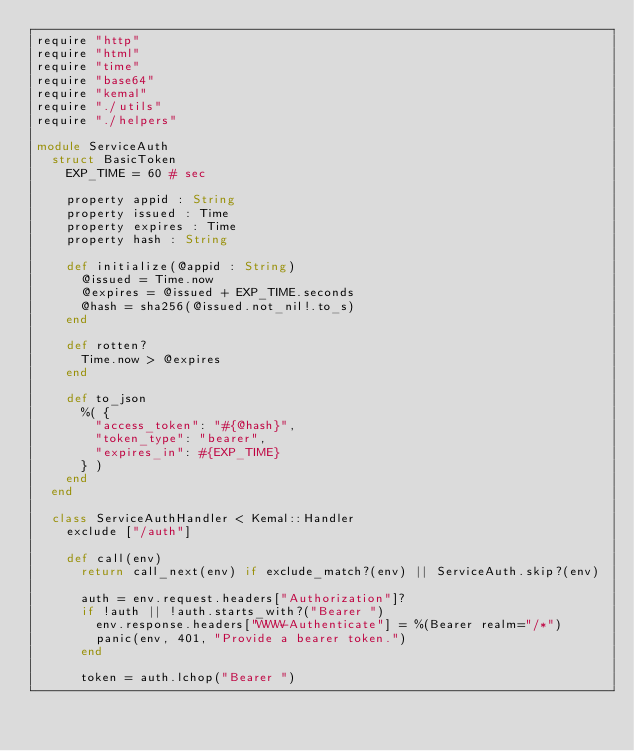Convert code to text. <code><loc_0><loc_0><loc_500><loc_500><_Crystal_>require "http"
require "html"
require "time"
require "base64"
require "kemal"
require "./utils"
require "./helpers"

module ServiceAuth
  struct BasicToken
    EXP_TIME = 60 # sec

    property appid : String
    property issued : Time
    property expires : Time
    property hash : String

    def initialize(@appid : String)
      @issued = Time.now
      @expires = @issued + EXP_TIME.seconds
      @hash = sha256(@issued.not_nil!.to_s)
    end

    def rotten?
      Time.now > @expires
    end

    def to_json
      %( {
        "access_token": "#{@hash}",
        "token_type": "bearer",
        "expires_in": #{EXP_TIME}
      } )
    end
  end

  class ServiceAuthHandler < Kemal::Handler
    exclude ["/auth"]

    def call(env)
      return call_next(env) if exclude_match?(env) || ServiceAuth.skip?(env)

      auth = env.request.headers["Authorization"]?
      if !auth || !auth.starts_with?("Bearer ")
        env.response.headers["WWW-Authenticate"] = %(Bearer realm="/*")
        panic(env, 401, "Provide a bearer token.")
      end

      token = auth.lchop("Bearer ")</code> 